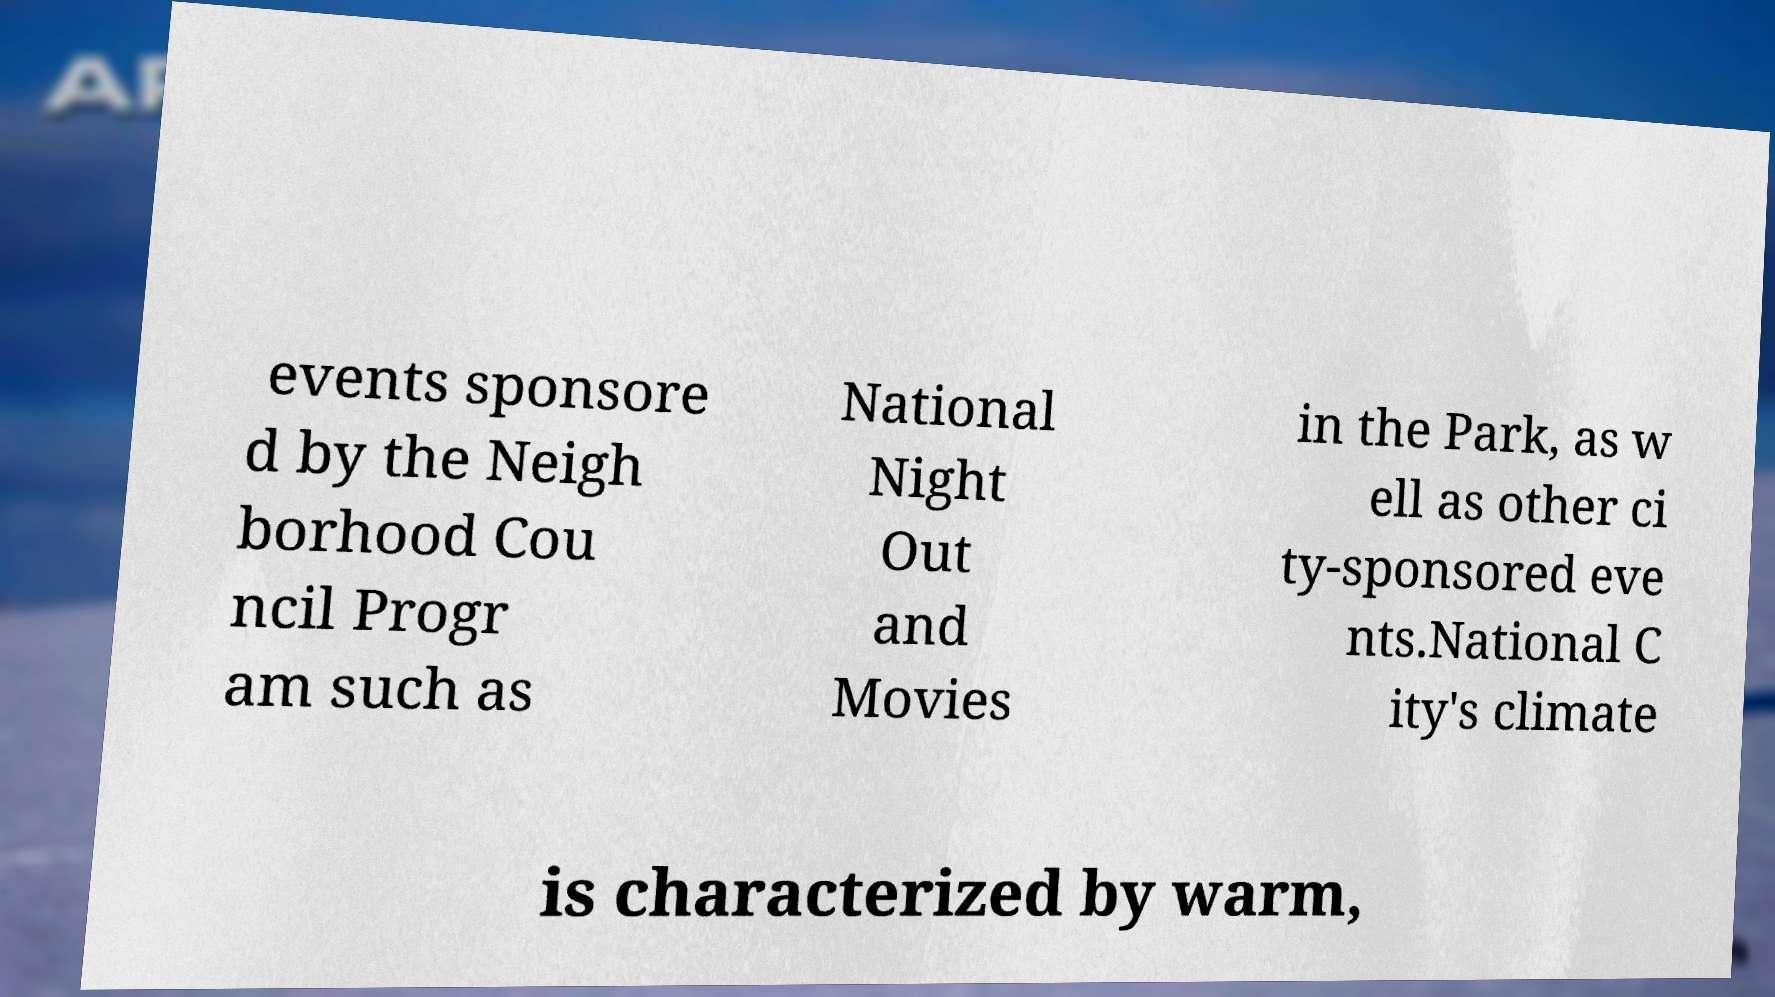Could you extract and type out the text from this image? events sponsore d by the Neigh borhood Cou ncil Progr am such as National Night Out and Movies in the Park, as w ell as other ci ty-sponsored eve nts.National C ity's climate is characterized by warm, 